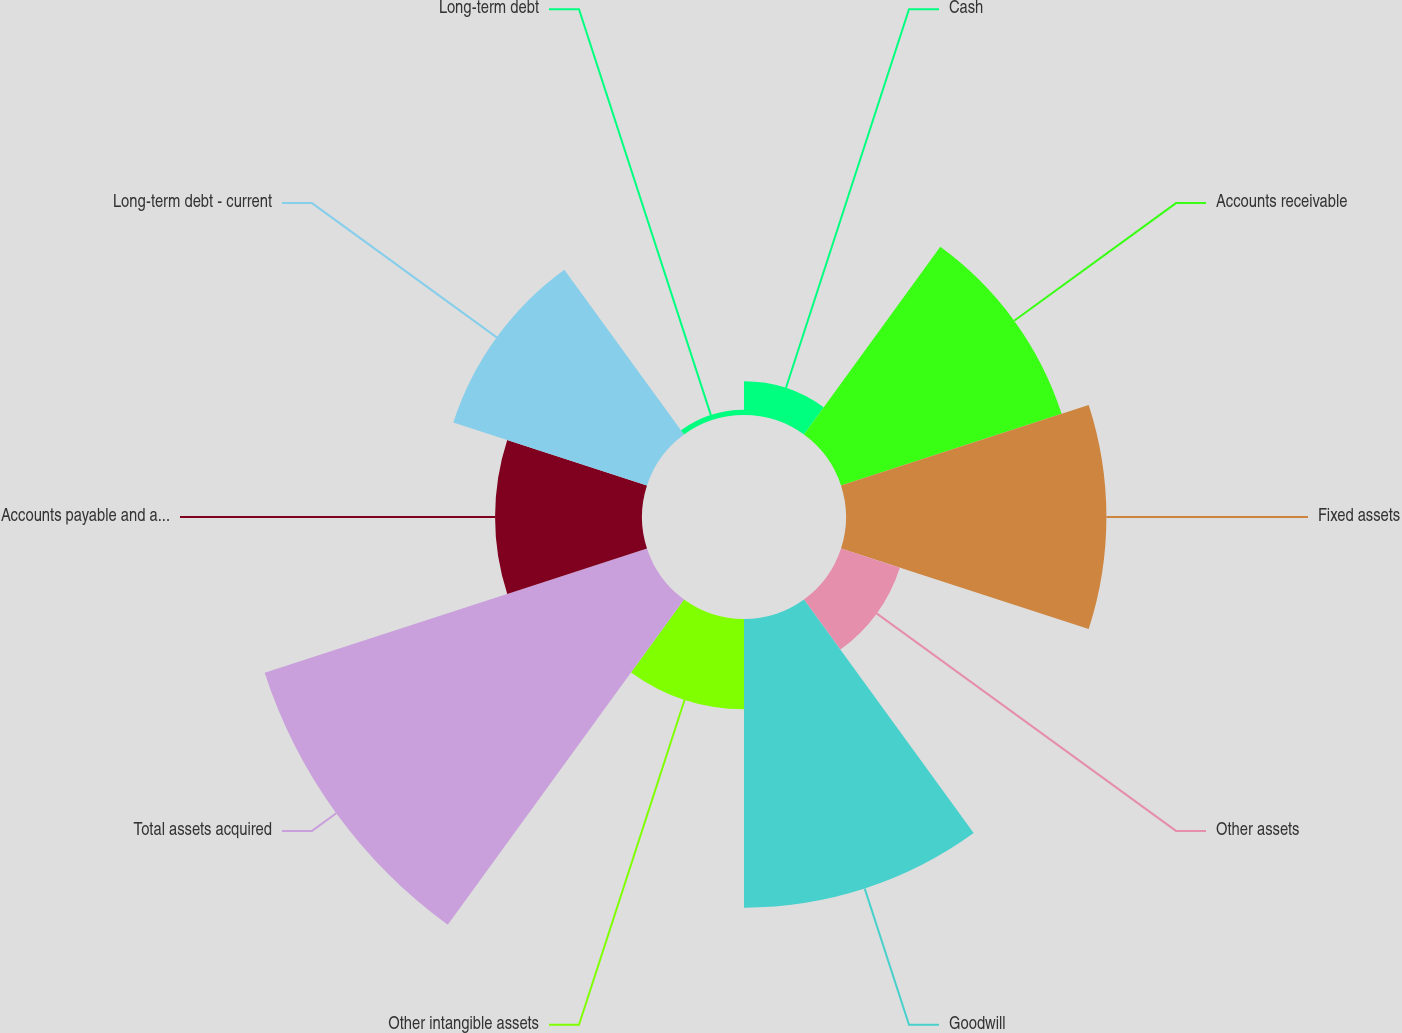<chart> <loc_0><loc_0><loc_500><loc_500><pie_chart><fcel>Cash<fcel>Accounts receivable<fcel>Fixed assets<fcel>Other assets<fcel>Goodwill<fcel>Other intangible assets<fcel>Total assets acquired<fcel>Accounts payable and accrued<fcel>Long-term debt - current<fcel>Long-term debt<nl><fcel>1.95%<fcel>13.45%<fcel>15.1%<fcel>3.59%<fcel>16.74%<fcel>5.23%<fcel>23.31%<fcel>8.52%<fcel>11.81%<fcel>0.3%<nl></chart> 